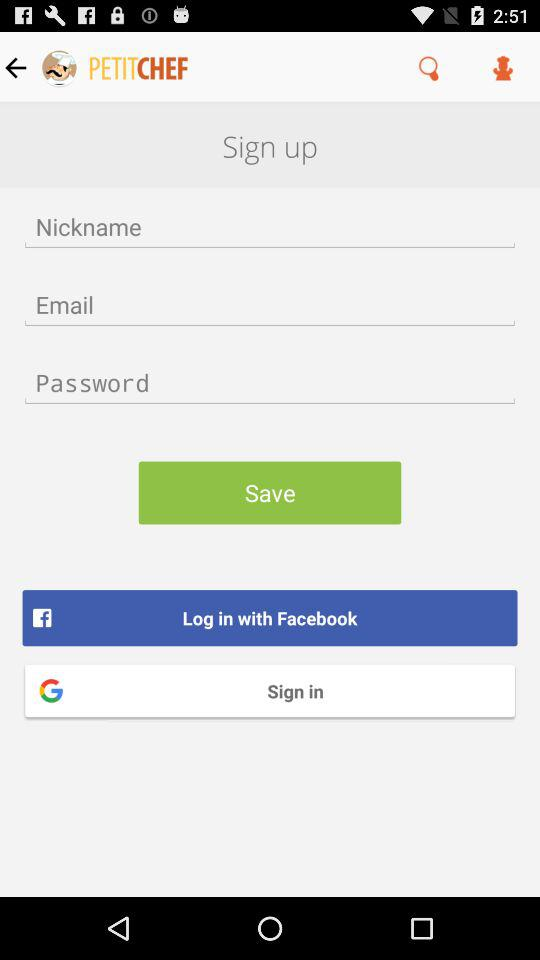Through what application can we log in? You can log in through "Facebook". 